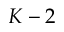Convert formula to latex. <formula><loc_0><loc_0><loc_500><loc_500>K - 2</formula> 